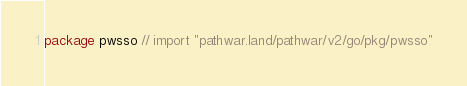<code> <loc_0><loc_0><loc_500><loc_500><_Go_>package pwsso // import "pathwar.land/pathwar/v2/go/pkg/pwsso"
</code> 